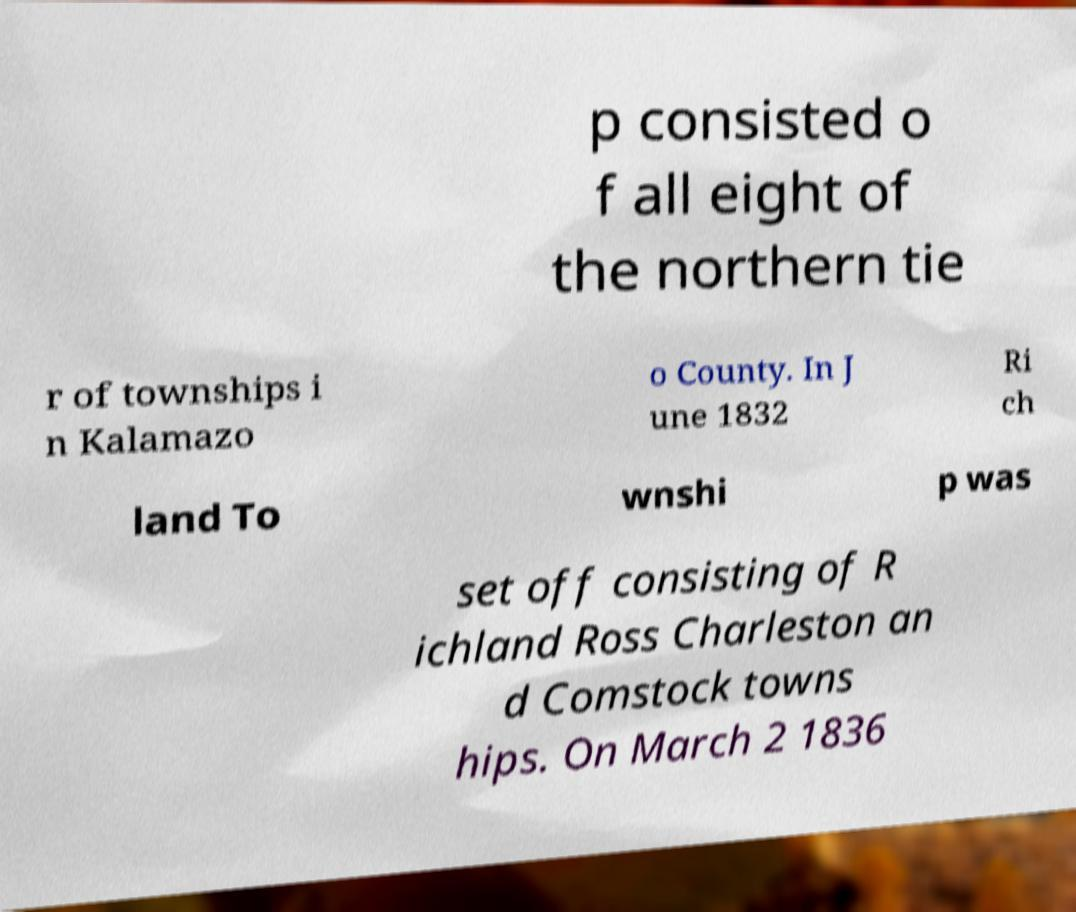Could you extract and type out the text from this image? p consisted o f all eight of the northern tie r of townships i n Kalamazo o County. In J une 1832 Ri ch land To wnshi p was set off consisting of R ichland Ross Charleston an d Comstock towns hips. On March 2 1836 